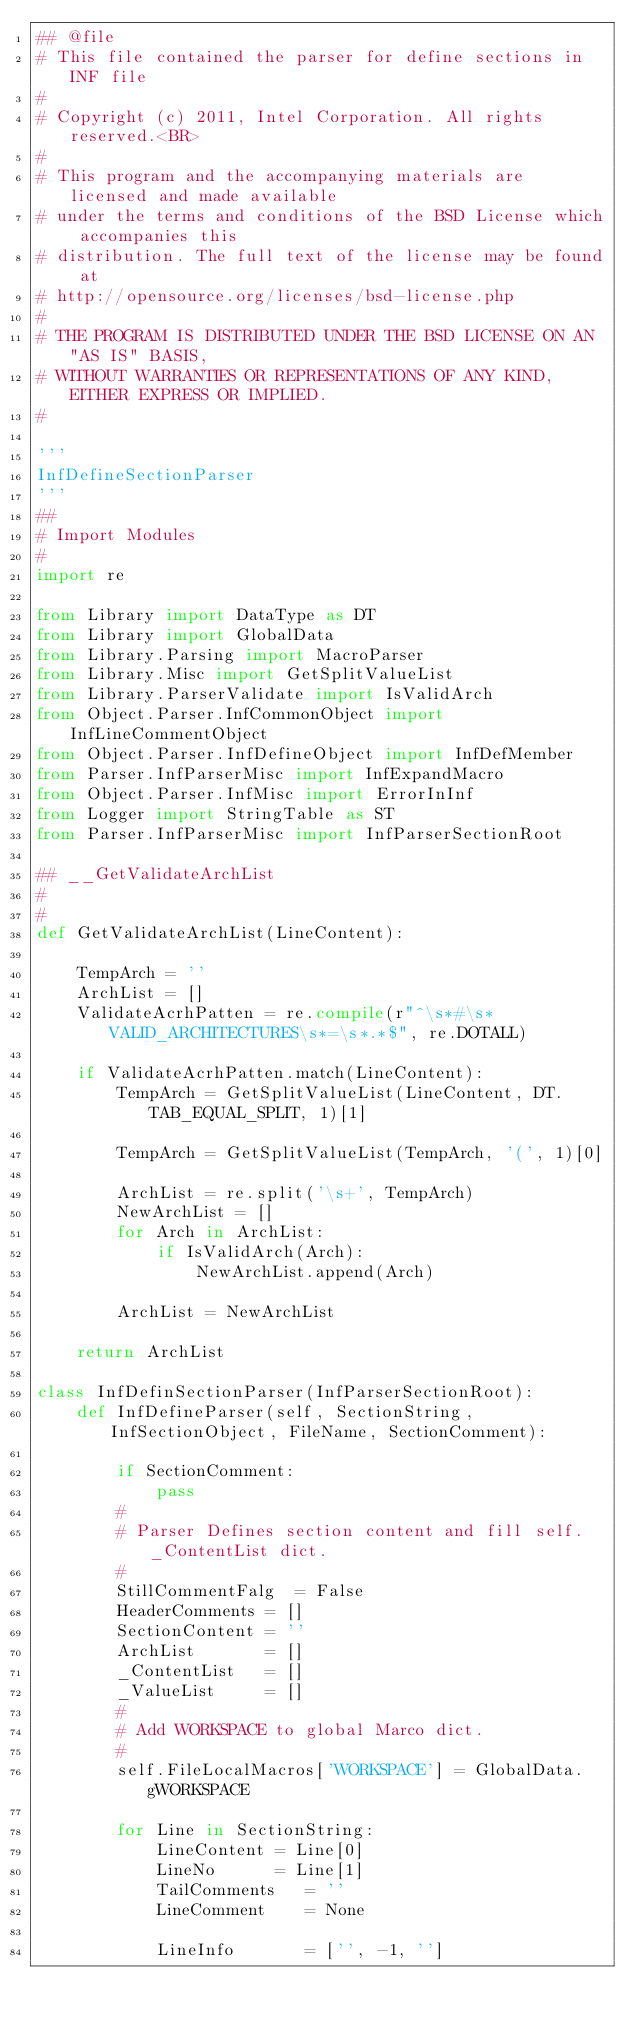<code> <loc_0><loc_0><loc_500><loc_500><_Python_>## @file
# This file contained the parser for define sections in INF file 
#
# Copyright (c) 2011, Intel Corporation. All rights reserved.<BR>
#
# This program and the accompanying materials are licensed and made available 
# under the terms and conditions of the BSD License which accompanies this 
# distribution. The full text of the license may be found at 
# http://opensource.org/licenses/bsd-license.php
#
# THE PROGRAM IS DISTRIBUTED UNDER THE BSD LICENSE ON AN "AS IS" BASIS,
# WITHOUT WARRANTIES OR REPRESENTATIONS OF ANY KIND, EITHER EXPRESS OR IMPLIED.
#

'''
InfDefineSectionParser
'''
##
# Import Modules
#
import re

from Library import DataType as DT
from Library import GlobalData
from Library.Parsing import MacroParser
from Library.Misc import GetSplitValueList
from Library.ParserValidate import IsValidArch
from Object.Parser.InfCommonObject import InfLineCommentObject
from Object.Parser.InfDefineObject import InfDefMember
from Parser.InfParserMisc import InfExpandMacro
from Object.Parser.InfMisc import ErrorInInf
from Logger import StringTable as ST
from Parser.InfParserMisc import InfParserSectionRoot

## __GetValidateArchList
#        
#
def GetValidateArchList(LineContent):
    
    TempArch = ''
    ArchList = []
    ValidateAcrhPatten = re.compile(r"^\s*#\s*VALID_ARCHITECTURES\s*=\s*.*$", re.DOTALL)
    
    if ValidateAcrhPatten.match(LineContent):
        TempArch = GetSplitValueList(LineContent, DT.TAB_EQUAL_SPLIT, 1)[1]
                                
        TempArch = GetSplitValueList(TempArch, '(', 1)[0]
                                
        ArchList = re.split('\s+', TempArch)
        NewArchList = []
        for Arch in ArchList:
            if IsValidArch(Arch):
                NewArchList.append(Arch)
        
        ArchList = NewArchList
        
    return ArchList   

class InfDefinSectionParser(InfParserSectionRoot):
    def InfDefineParser(self, SectionString, InfSectionObject, FileName, SectionComment):
        
        if SectionComment:
            pass
        #
        # Parser Defines section content and fill self._ContentList dict.
        #
        StillCommentFalg  = False
        HeaderComments = []
        SectionContent = ''
        ArchList       = []
        _ContentList   = []
        _ValueList     = []
        #
        # Add WORKSPACE to global Marco dict.
        #
        self.FileLocalMacros['WORKSPACE'] = GlobalData.gWORKSPACE
        
        for Line in SectionString:
            LineContent = Line[0]
            LineNo      = Line[1]
            TailComments   = ''
            LineComment    = None
            
            LineInfo       = ['', -1, '']</code> 